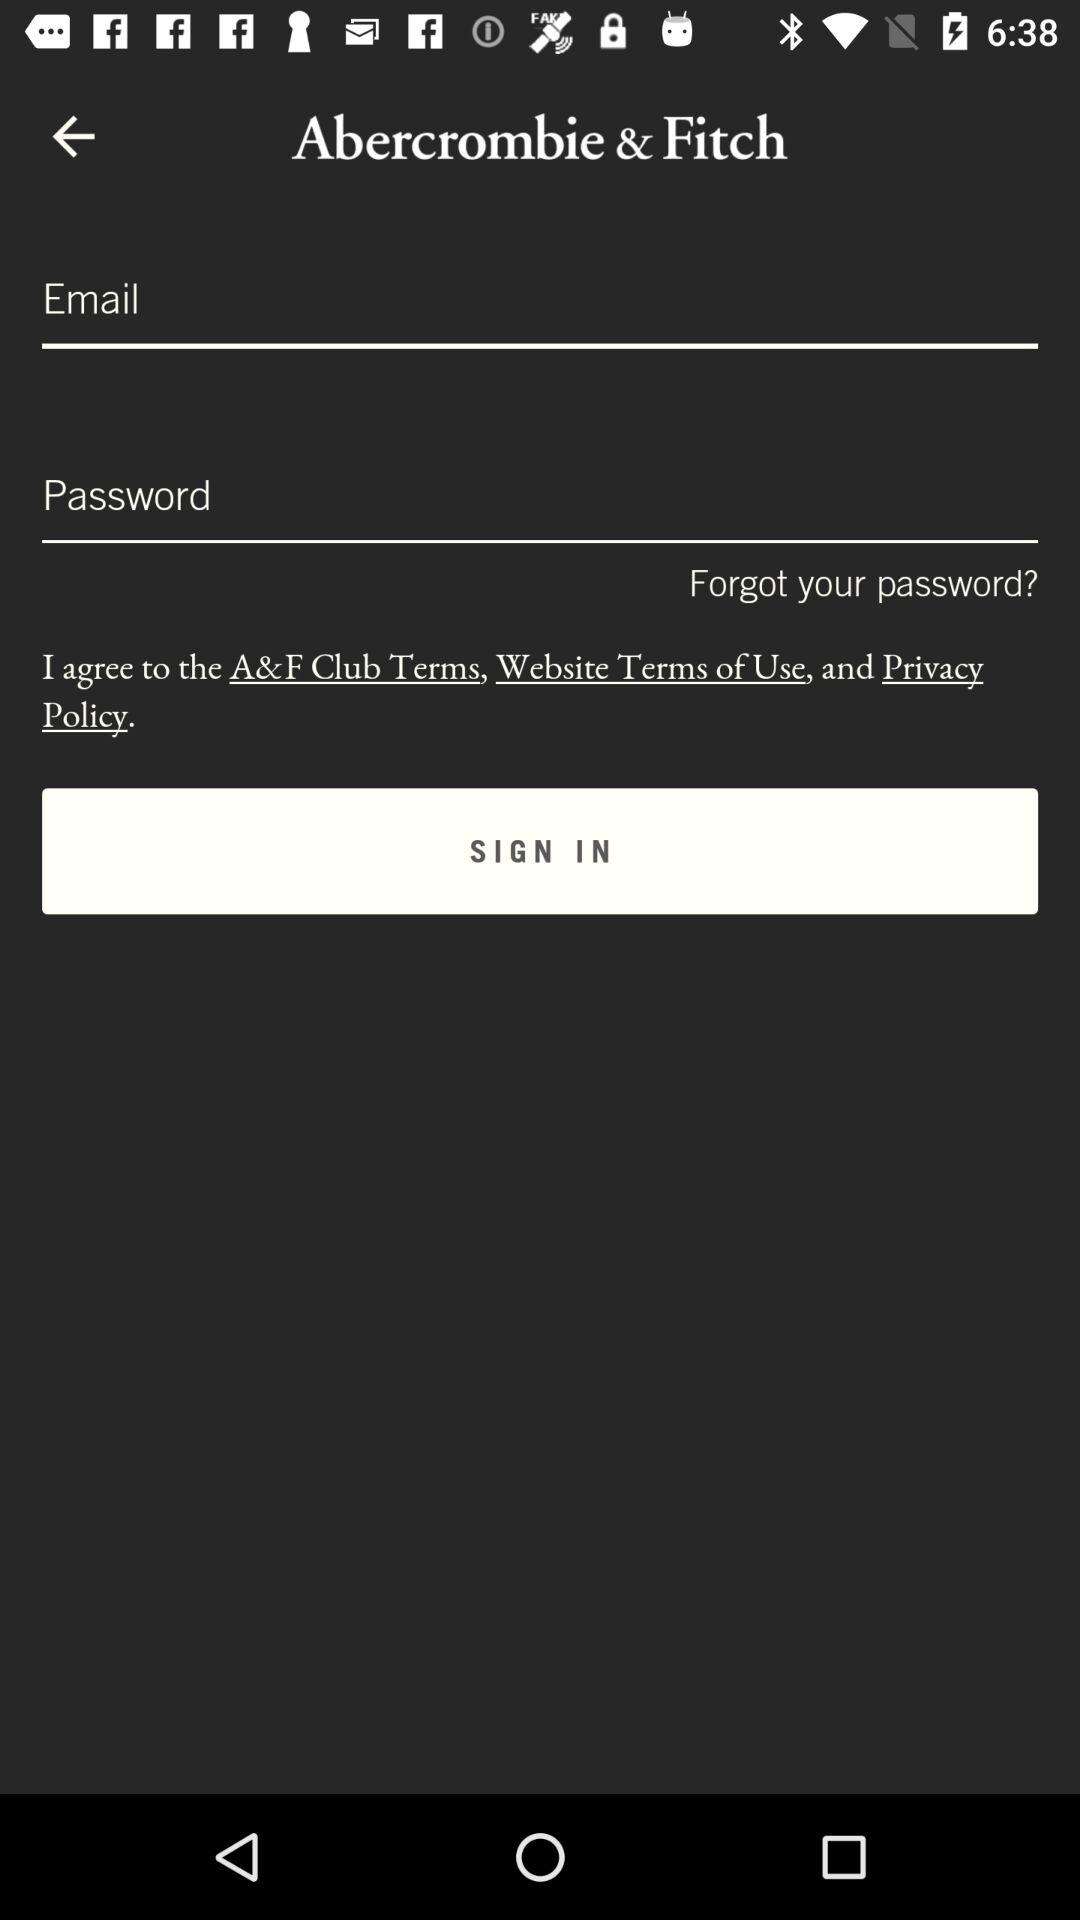How many fields are there to fill in?
Answer the question using a single word or phrase. 2 